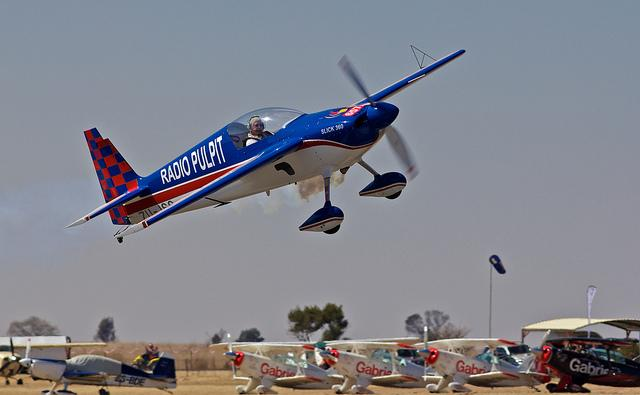What is the man doing in the front of the blue plane?

Choices:
A) selling it
B) repairing it
C) flying it
D) washing it flying it 